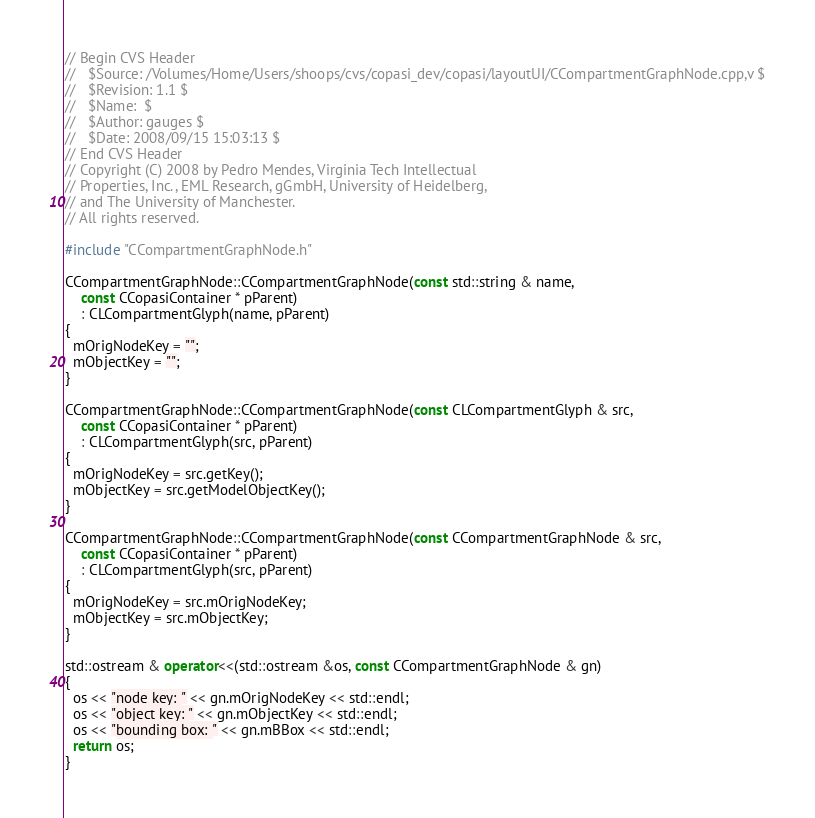<code> <loc_0><loc_0><loc_500><loc_500><_C++_>// Begin CVS Header
//   $Source: /Volumes/Home/Users/shoops/cvs/copasi_dev/copasi/layoutUI/CCompartmentGraphNode.cpp,v $
//   $Revision: 1.1 $
//   $Name:  $
//   $Author: gauges $
//   $Date: 2008/09/15 15:03:13 $
// End CVS Header
// Copyright (C) 2008 by Pedro Mendes, Virginia Tech Intellectual
// Properties, Inc., EML Research, gGmbH, University of Heidelberg,
// and The University of Manchester.
// All rights reserved.

#include "CCompartmentGraphNode.h"

CCompartmentGraphNode::CCompartmentGraphNode(const std::string & name,
    const CCopasiContainer * pParent)
    : CLCompartmentGlyph(name, pParent)
{
  mOrigNodeKey = "";
  mObjectKey = "";
}

CCompartmentGraphNode::CCompartmentGraphNode(const CLCompartmentGlyph & src,
    const CCopasiContainer * pParent)
    : CLCompartmentGlyph(src, pParent)
{
  mOrigNodeKey = src.getKey();
  mObjectKey = src.getModelObjectKey();
}

CCompartmentGraphNode::CCompartmentGraphNode(const CCompartmentGraphNode & src,
    const CCopasiContainer * pParent)
    : CLCompartmentGlyph(src, pParent)
{
  mOrigNodeKey = src.mOrigNodeKey;
  mObjectKey = src.mObjectKey;
}

std::ostream & operator<<(std::ostream &os, const CCompartmentGraphNode & gn)
{
  os << "node key: " << gn.mOrigNodeKey << std::endl;
  os << "object key: " << gn.mObjectKey << std::endl;
  os << "bounding box: " << gn.mBBox << std::endl;
  return os;
}
</code> 